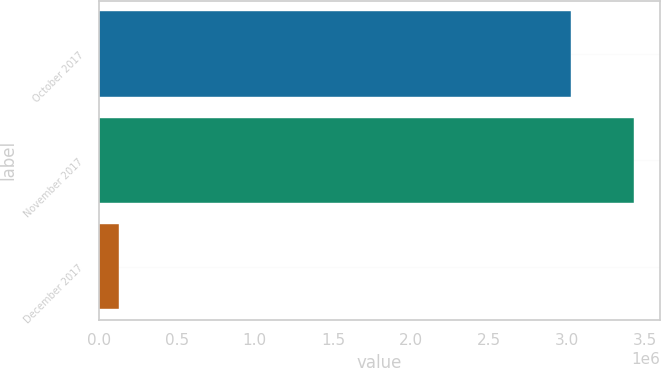Convert chart to OTSL. <chart><loc_0><loc_0><loc_500><loc_500><bar_chart><fcel>October 2017<fcel>November 2017<fcel>December 2017<nl><fcel>3.02193e+06<fcel>3.4249e+06<fcel>128943<nl></chart> 